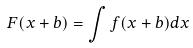<formula> <loc_0><loc_0><loc_500><loc_500>F ( x + b ) = \int f ( x + b ) d x</formula> 